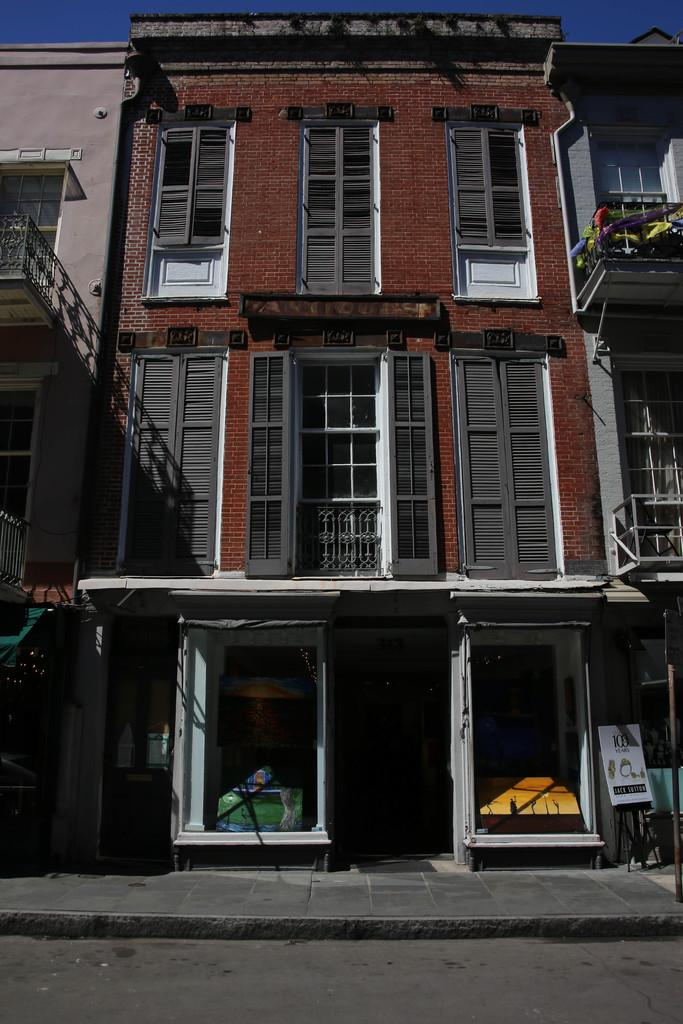What type of structures can be seen in the image? There are buildings in the image. What architectural features are visible on the buildings? There are windows and at least one door visible on the buildings. What is located at the bottom of the image? There is a road at the bottom of the image. What is visible at the top of the image? The sky is visible at the top of the image. What type of juice is being served at the rest stop in the image? There is no juice or rest stop present in the image; it features buildings, windows, doors, a road, and the sky. 